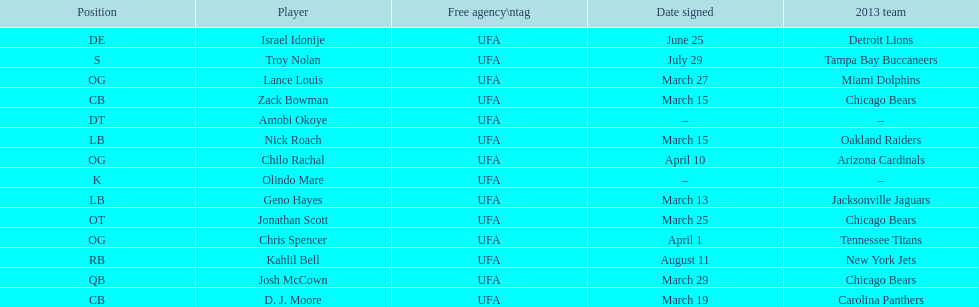Geno hayes and nick roach both played which position? LB. 